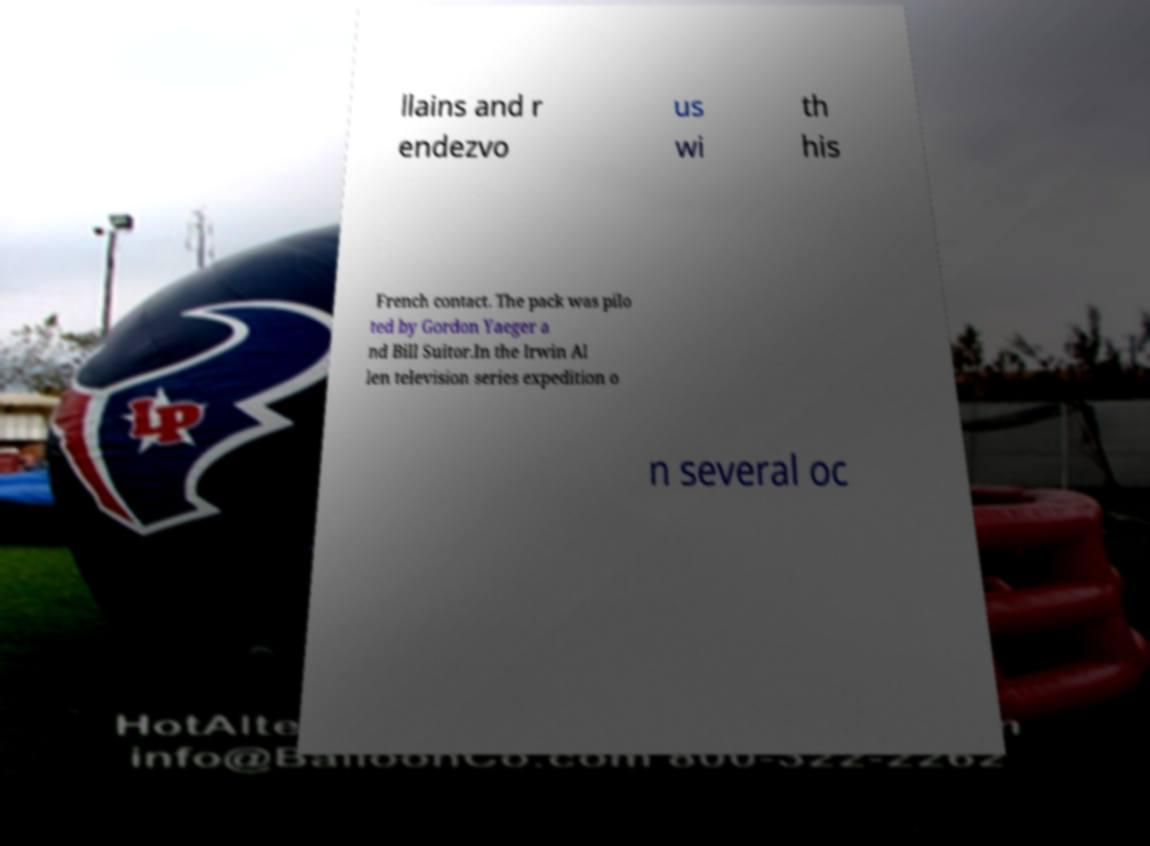I need the written content from this picture converted into text. Can you do that? llains and r endezvo us wi th his French contact. The pack was pilo ted by Gordon Yaeger a nd Bill Suitor.In the Irwin Al len television series expedition o n several oc 